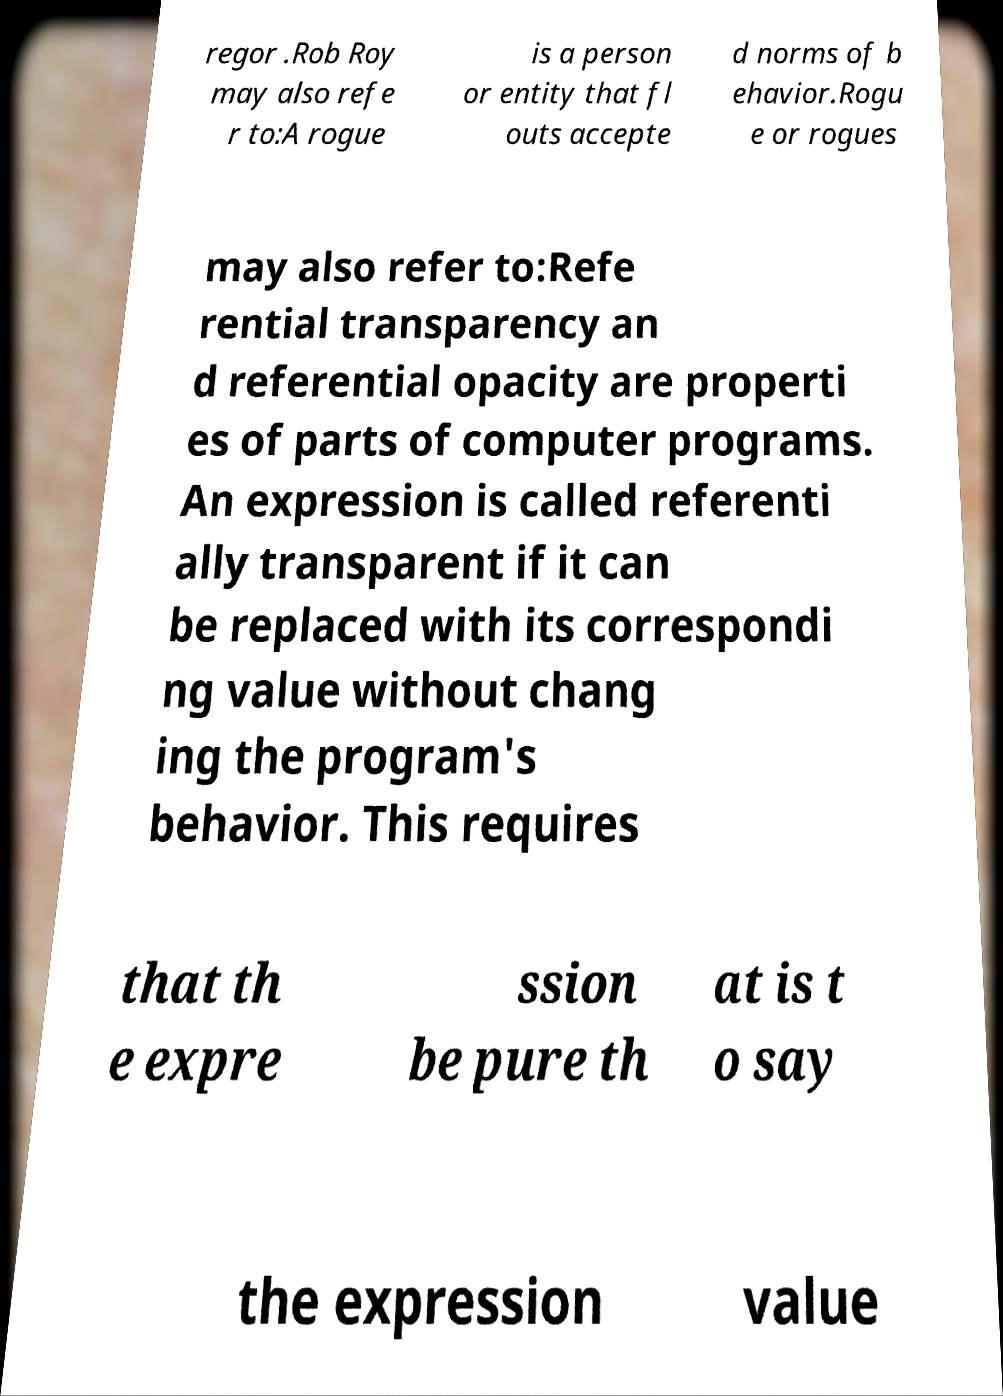There's text embedded in this image that I need extracted. Can you transcribe it verbatim? regor .Rob Roy may also refe r to:A rogue is a person or entity that fl outs accepte d norms of b ehavior.Rogu e or rogues may also refer to:Refe rential transparency an d referential opacity are properti es of parts of computer programs. An expression is called referenti ally transparent if it can be replaced with its correspondi ng value without chang ing the program's behavior. This requires that th e expre ssion be pure th at is t o say the expression value 